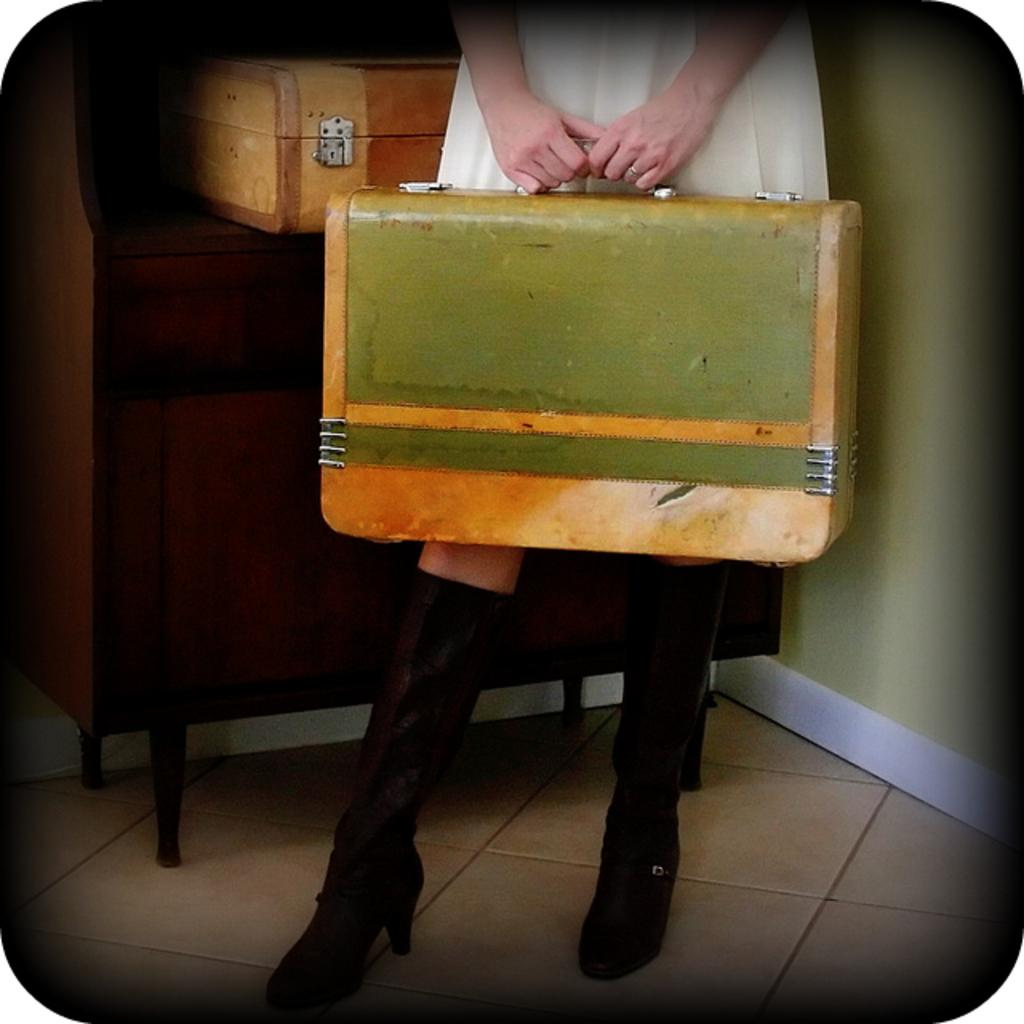What is the main subject of the image? There is a human in the image. What is the human holding in the image? The human is holding a box. Can you describe the placement of the boxes in the image? There is another box behind the human, and both boxes are placed on a wooden cupboard. What can be seen on the bottom part of the image? The bottom floor is visible in the image. What is on the right side of the image? There is a wall on the right side of the image. Is there a water fountain arch visible in the image? No, there is no water fountain arch present in the image. What arithmetic problem is the human solving in the image? There is no indication of the human solving an arithmetic problem in the image. 